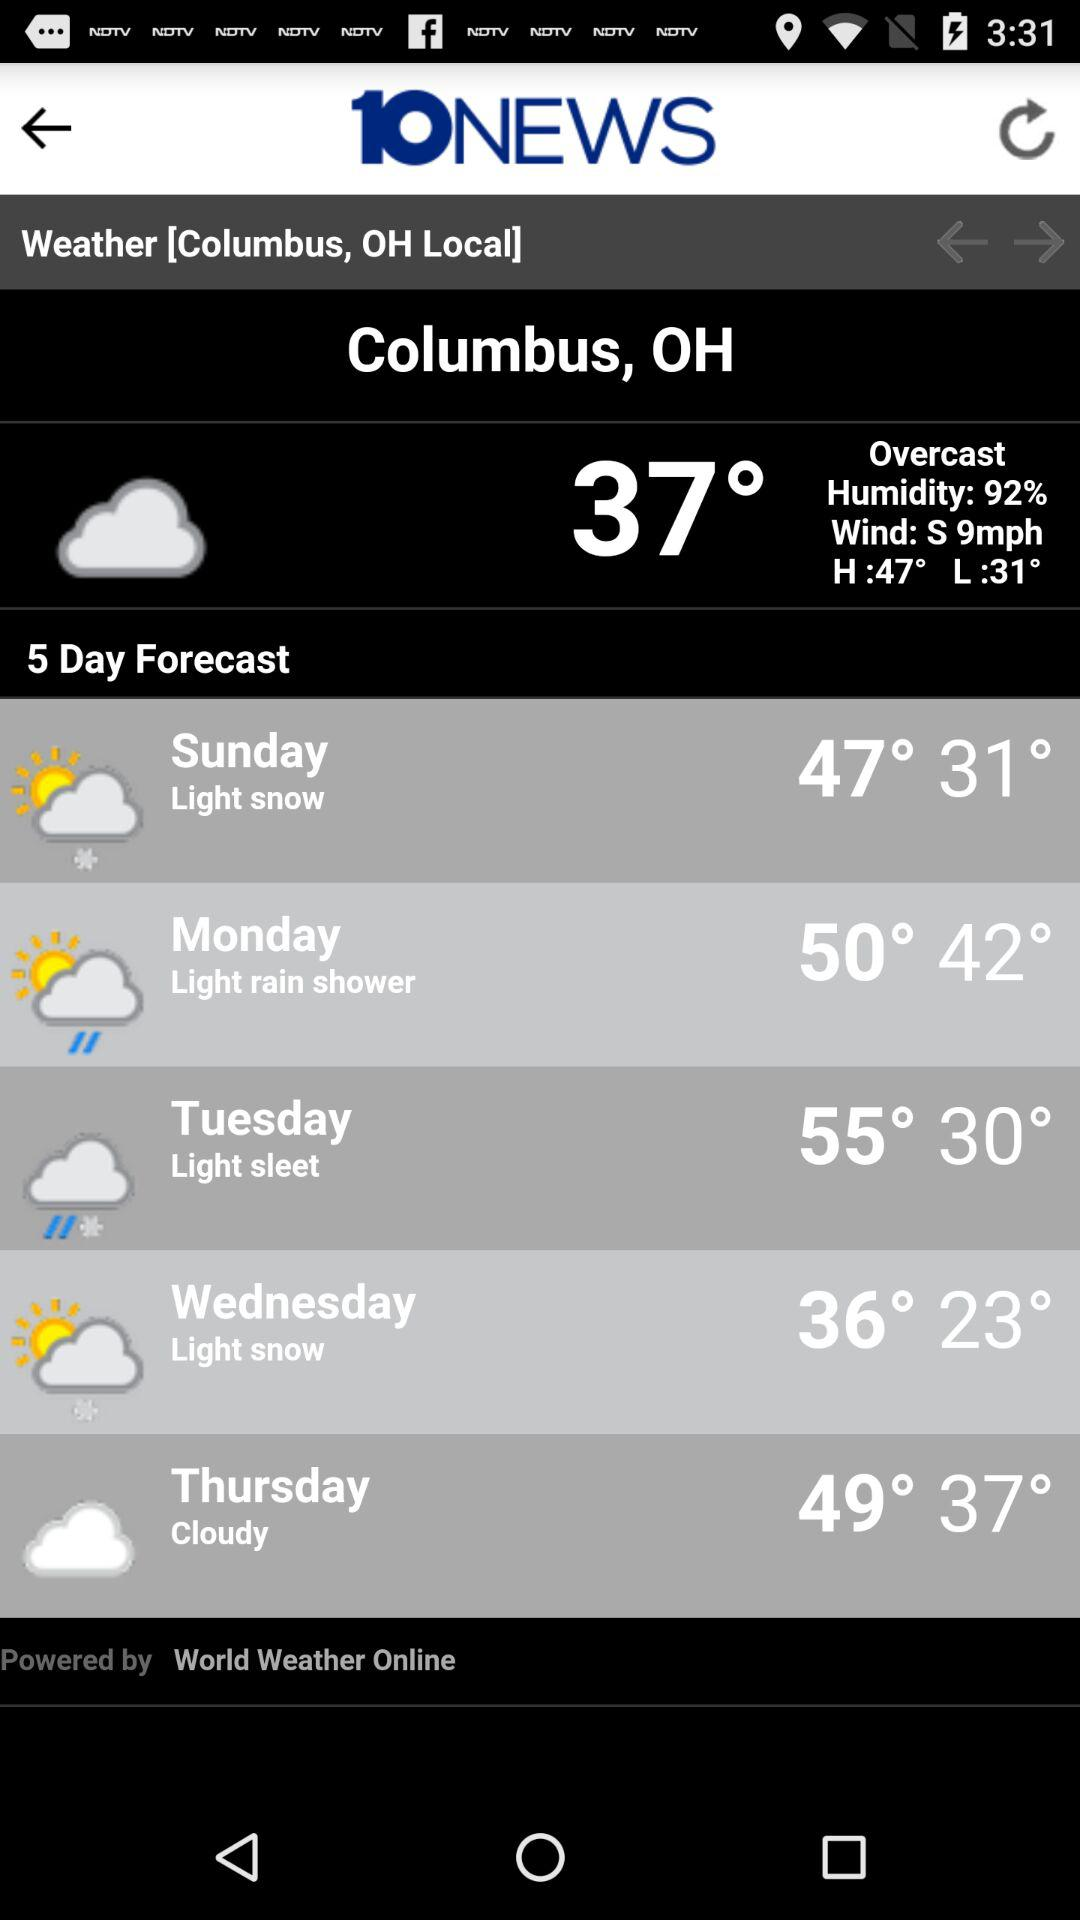What day will have a temperature of 50 degrees? The day will be Monday. 